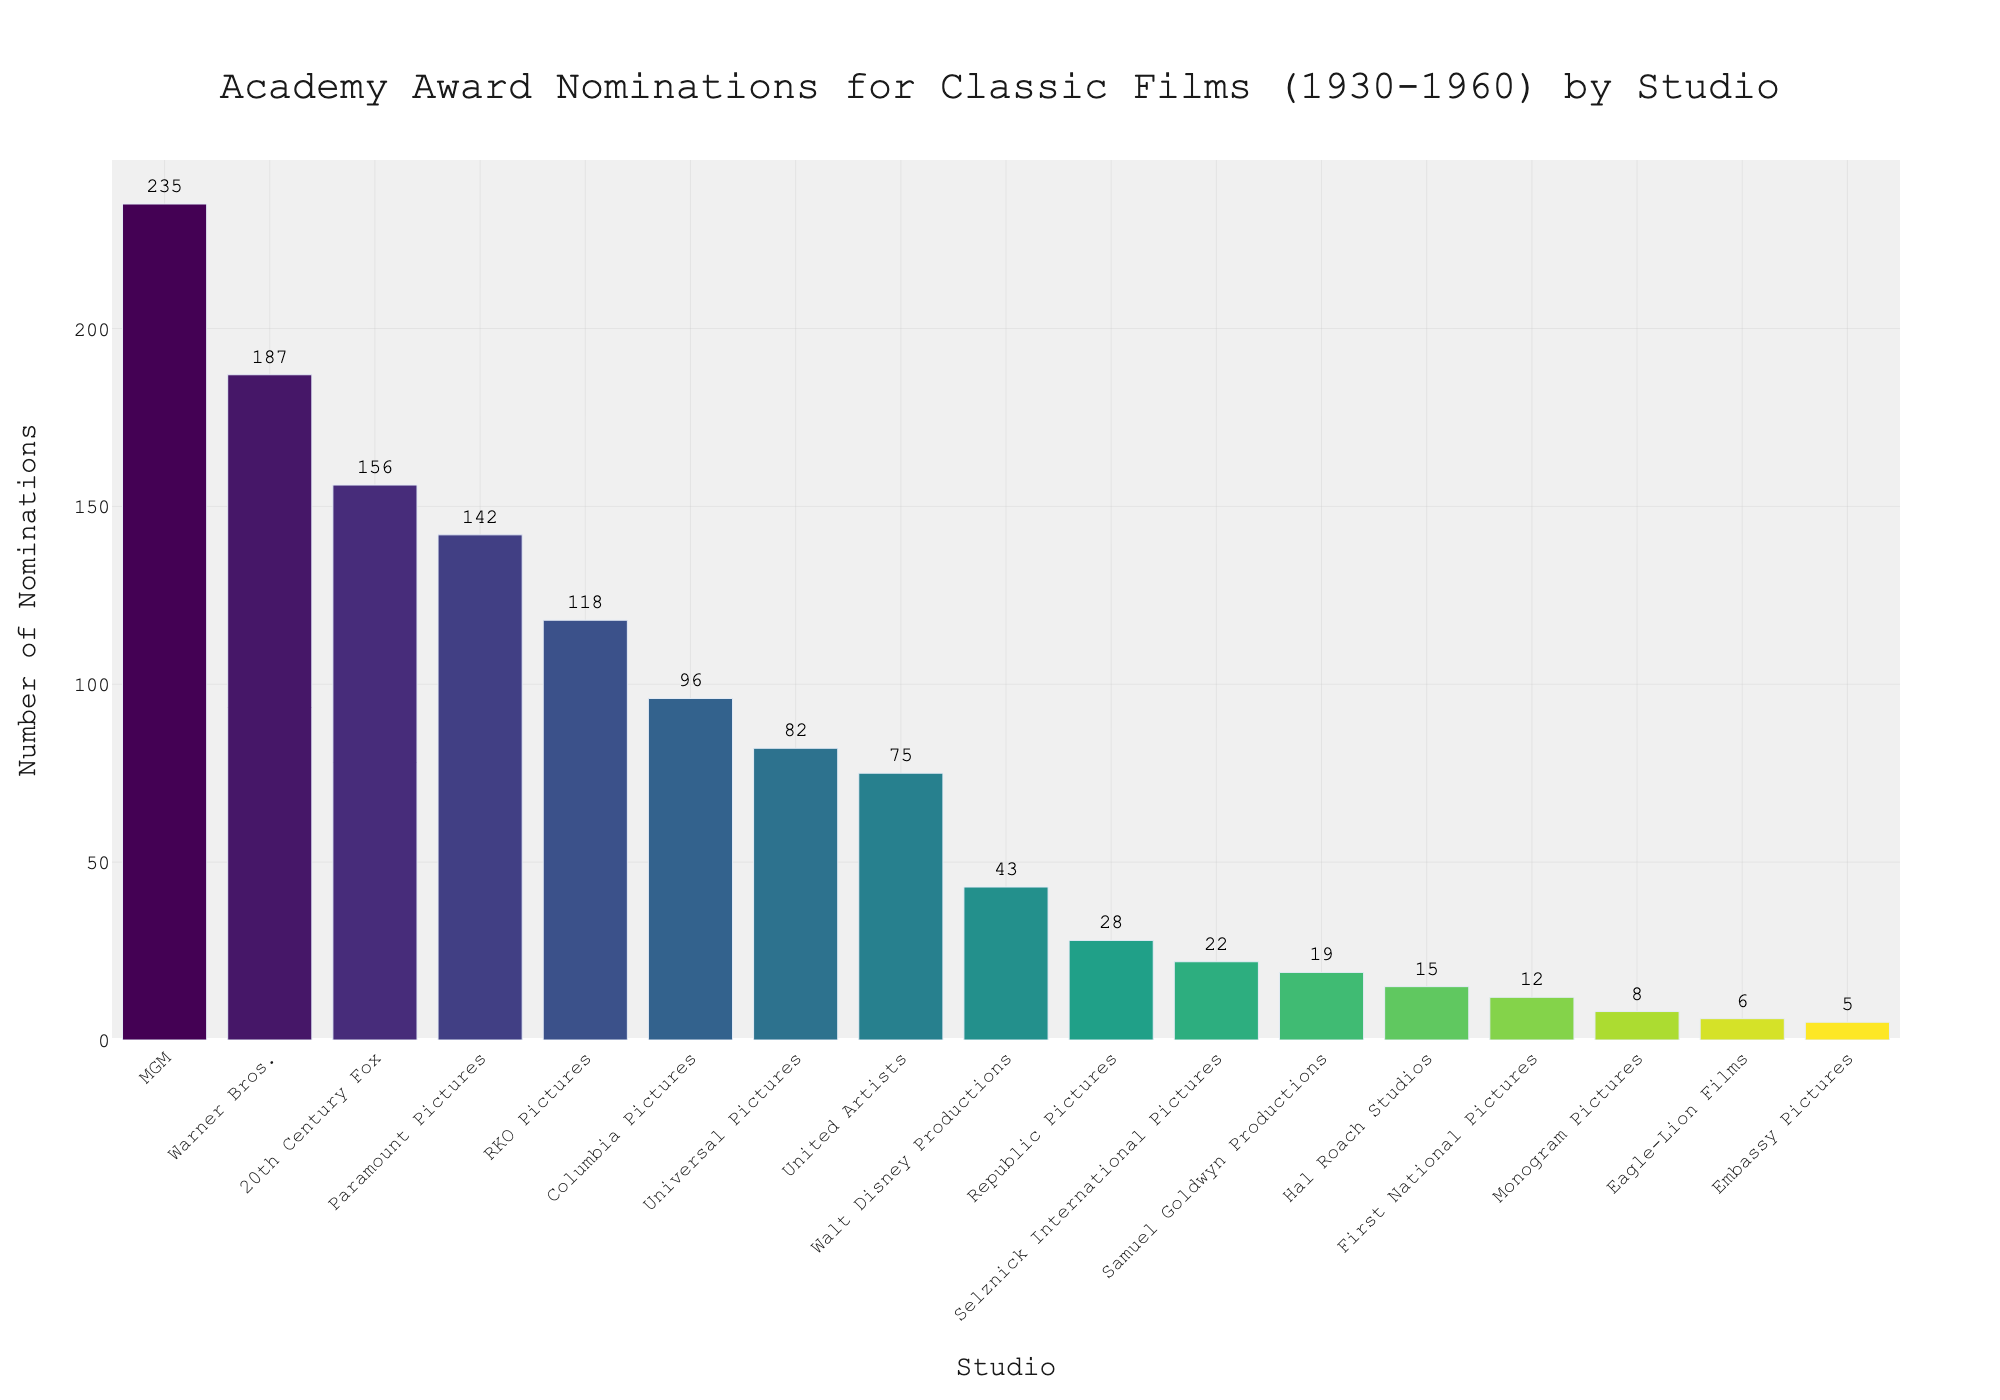Which studio received the most Academy Award nominations? The figure shows the number of Academy Award nominations for each studio. The bar with the greatest height represents MGM with 235 nominations.
Answer: MGM Which studio received the least Academy Award nominations? The figure shows the number of Academy Award nominations for each studio. The bar with the shortest height represents Embassy Pictures with 5 nominations.
Answer: Embassy Pictures How many more nominations did Warner Bros. receive compared to Universal Pictures? Warner Bros. received 187 nominations and Universal Pictures received 82 nominations. Subtracting the two gives 187 - 82.
Answer: 105 What is the sum of nominations received by Columbia Pictures and RKO Pictures? Columbia Pictures received 96 nominations and RKO Pictures received 118 nominations. Adding the two gives 96 + 118.
Answer: 214 How many studios received over 100 nominations? Considering the bars for MGM, Warner Bros., 20th Century Fox, Paramount Pictures, and RKO Pictures, there are 5 studios that received more than 100 nominations.
Answer: 5 Which three studios received the most nominations? The tallest three bars represent the studios. From highest to lowest, they are MGM, Warner Bros., and 20th Century Fox.
Answer: MGM, Warner Bros., 20th Century Fox Is the number of nominations for Universal Pictures closer to United Artists or Columbia Pictures? Universal Pictures received 82 nominations, United Artists received 75, and Columbia Pictures received 96. Calculate the absolute differences:
Answer: United Artists Compare the total number of nominations for Selznick International Pictures and Samuel Goldwyn Productions. Which studio has more, and by how many? Selznick International Pictures received 22 nominations and Samuel Goldwyn Productions received 19 nominations. Subtracting the two gives 22 - 19.
Answer: Selznick International Pictures by 3 What's the average number of nominations for the top 3 studios? The top 3 studios are MGM, Warner Bros., and 20th Century Fox with 235, 187, and 156 nominations respectively. The average is (235 + 187 + 156) / 3.
Answer: 192.67 